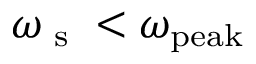Convert formula to latex. <formula><loc_0><loc_0><loc_500><loc_500>\omega _ { s } < \omega _ { p e a k }</formula> 